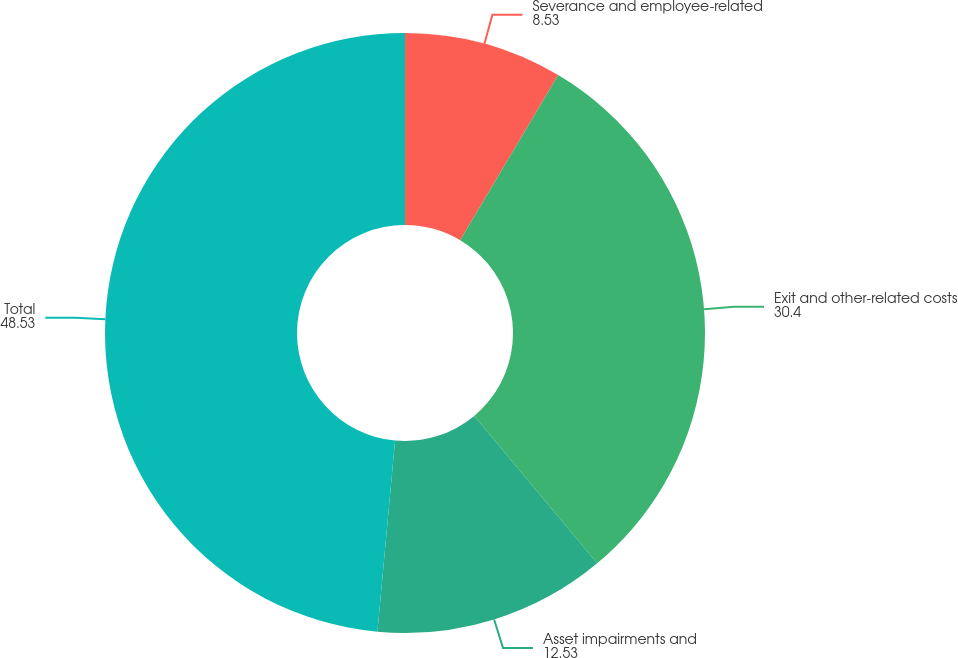Convert chart to OTSL. <chart><loc_0><loc_0><loc_500><loc_500><pie_chart><fcel>Severance and employee-related<fcel>Exit and other-related costs<fcel>Asset impairments and<fcel>Total<nl><fcel>8.53%<fcel>30.4%<fcel>12.53%<fcel>48.53%<nl></chart> 